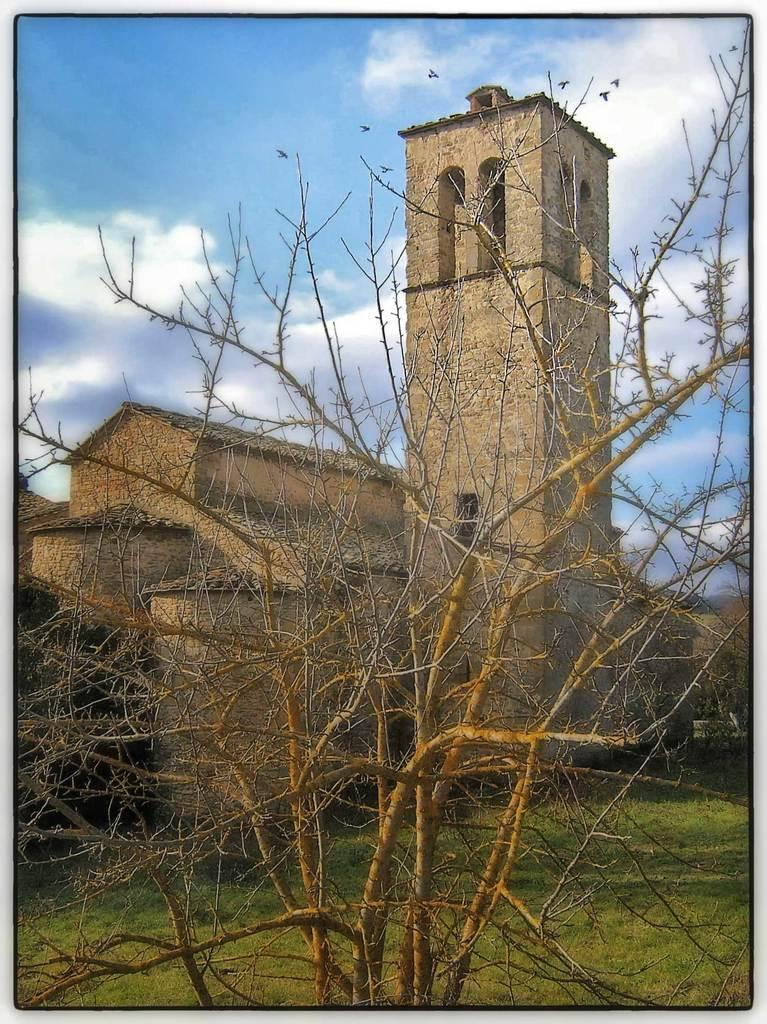What type of structure is visible in the image? There is a fort in the image. What is the surrounding landscape like? There is grass around the fort. What can be seen in the foreground of the image? There is a dry plant in the foreground of the image. What direction is the bushes growing in the image? There are no bushes present in the image; it only features a fort, grass, and a dry plant. 